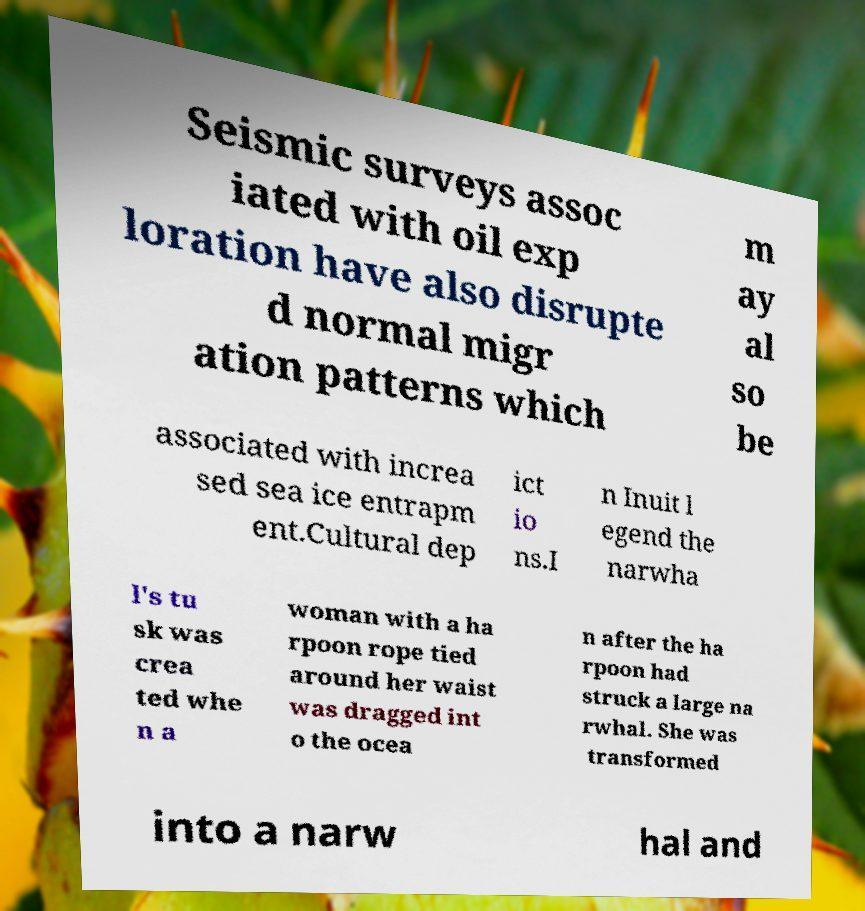Could you assist in decoding the text presented in this image and type it out clearly? Seismic surveys assoc iated with oil exp loration have also disrupte d normal migr ation patterns which m ay al so be associated with increa sed sea ice entrapm ent.Cultural dep ict io ns.I n Inuit l egend the narwha l's tu sk was crea ted whe n a woman with a ha rpoon rope tied around her waist was dragged int o the ocea n after the ha rpoon had struck a large na rwhal. She was transformed into a narw hal and 